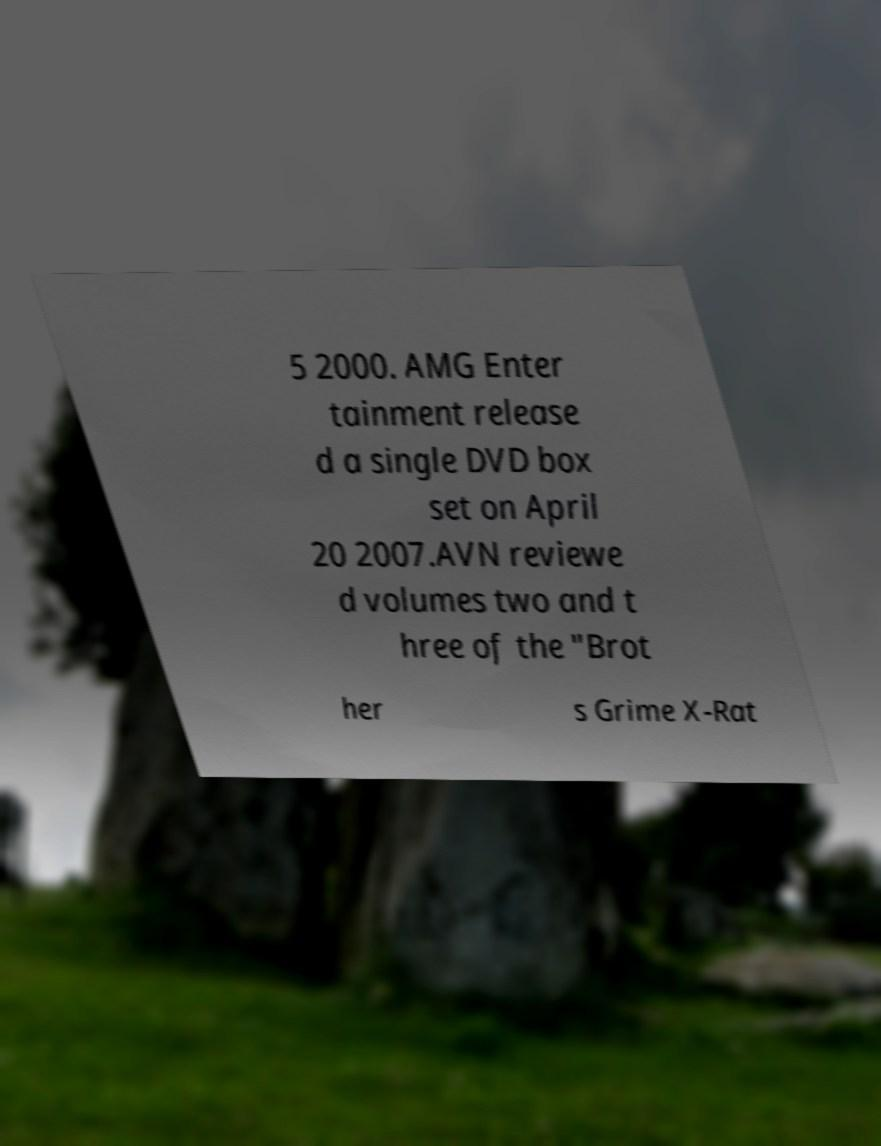Please identify and transcribe the text found in this image. 5 2000. AMG Enter tainment release d a single DVD box set on April 20 2007.AVN reviewe d volumes two and t hree of the "Brot her s Grime X-Rat 